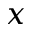<formula> <loc_0><loc_0><loc_500><loc_500>x</formula> 